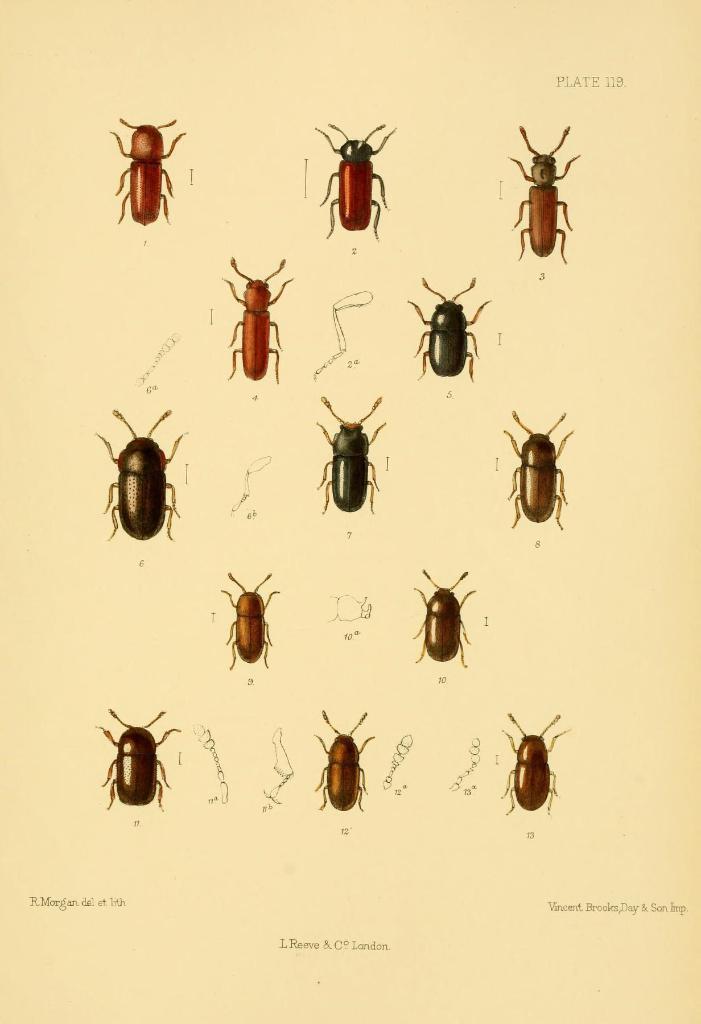Can you describe this image briefly? In this image there is graphical images of insects and there are some text written on the image. 